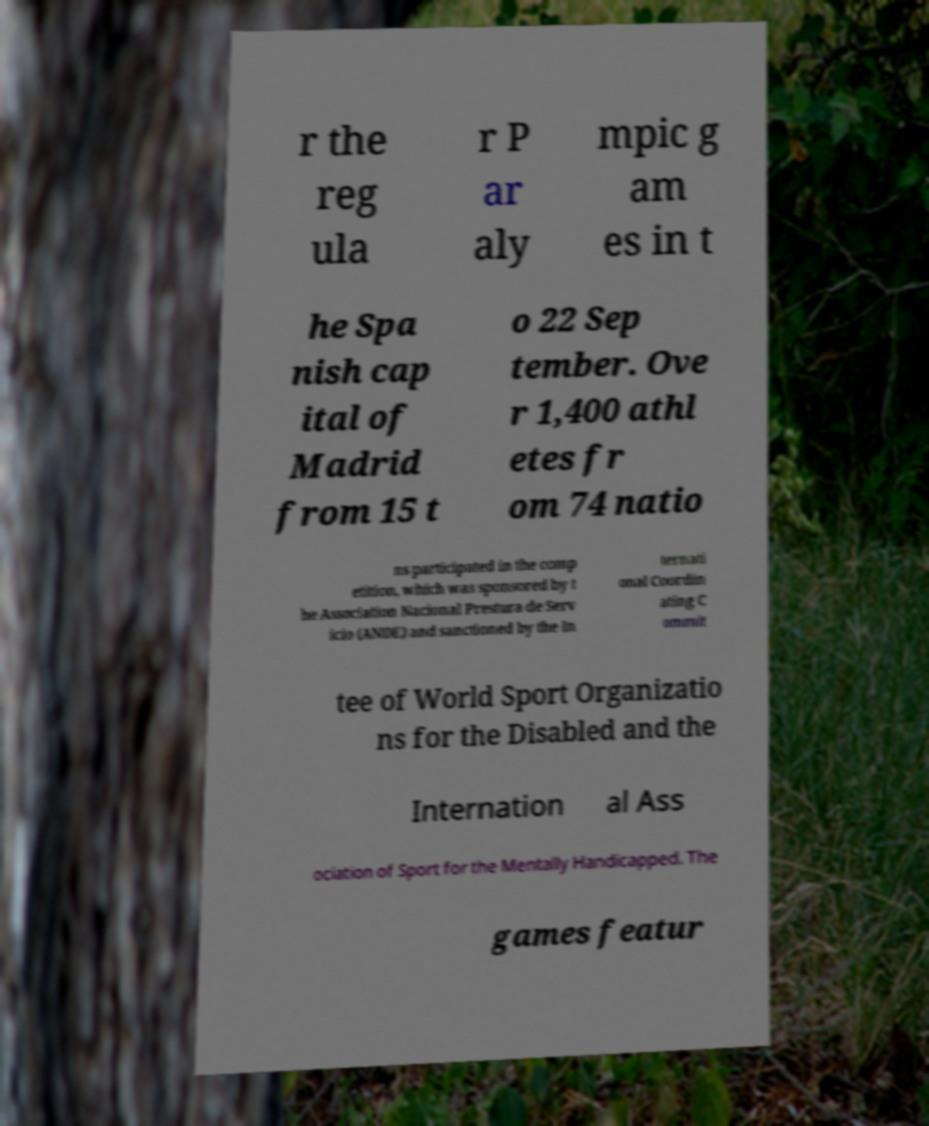What messages or text are displayed in this image? I need them in a readable, typed format. r the reg ula r P ar aly mpic g am es in t he Spa nish cap ital of Madrid from 15 t o 22 Sep tember. Ove r 1,400 athl etes fr om 74 natio ns participated in the comp etition, which was sponsored by t he Association Nacional Prestura de Serv icio (ANDE) and sanctioned by the In ternati onal Coordin ating C ommit tee of World Sport Organizatio ns for the Disabled and the Internation al Ass ociation of Sport for the Mentally Handicapped. The games featur 